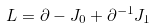Convert formula to latex. <formula><loc_0><loc_0><loc_500><loc_500>L = \partial - J _ { 0 } + \partial ^ { - 1 } J _ { 1 }</formula> 